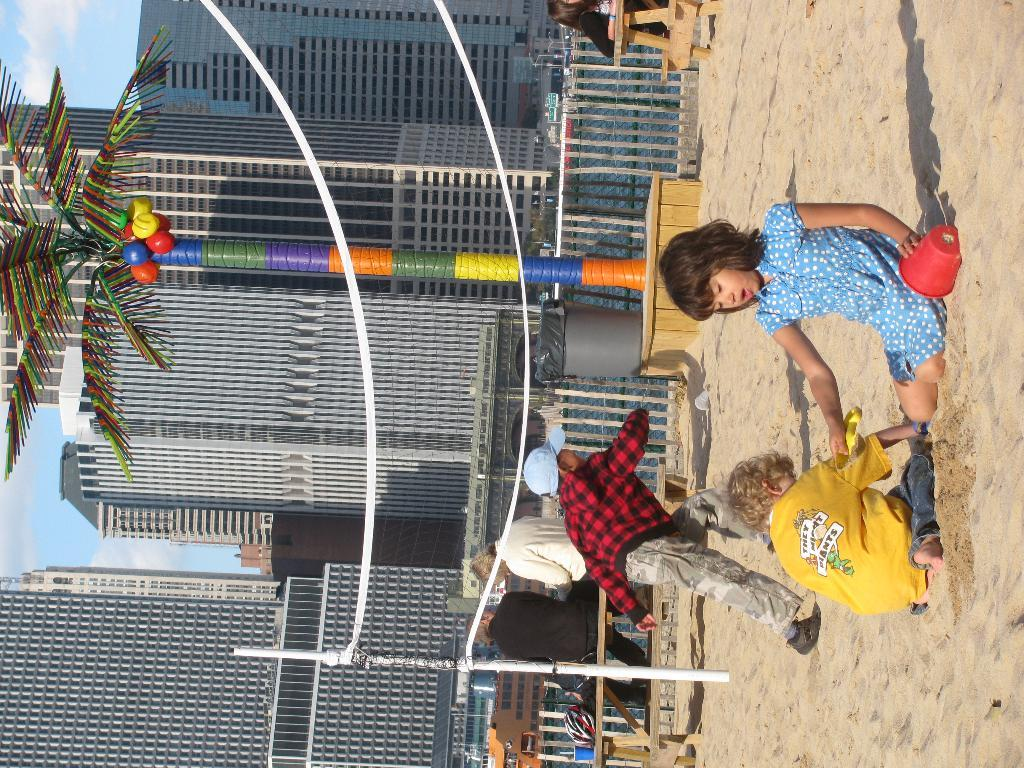What are the kids sitting on in the image? The kids are sitting on sand in the image. What is one of the kids holding? One of the kids is holding a mug. What is the boy in the image doing? The boy is running. What can be seen in the image that might be used for playing a game? There is a net visible in the image. What can be seen in the background of the image? In the background, there are people, buildings, a tree, and the sky. What type of umbrella is being used by the governor in the image? There is no governor or umbrella present in the image. What base is supporting the tree in the image? The image does not show the base of the tree; it only shows the tree itself. 